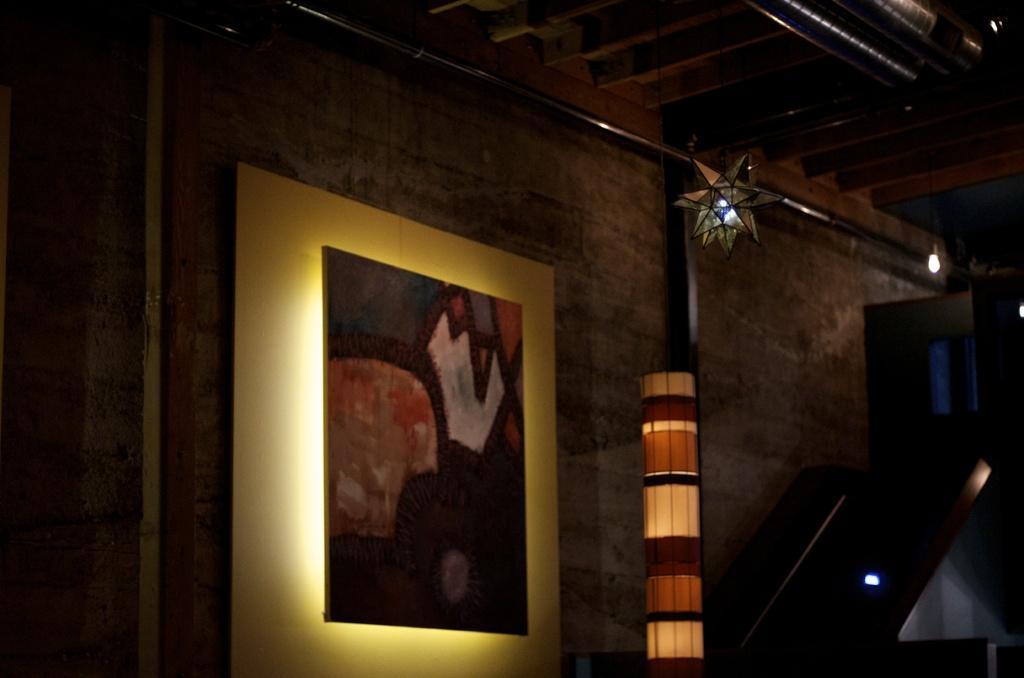How would you summarize this image in a sentence or two? In this picture we can see board on the wall, lamp, lights and decorative item. 